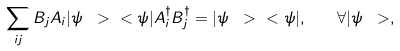Convert formula to latex. <formula><loc_0><loc_0><loc_500><loc_500>\sum _ { i j } B _ { j } A _ { i } | \psi \ > \ < \psi | A _ { i } ^ { \dag } B _ { j } ^ { \dag } = | \psi \ > \ < \psi | , \quad \forall | \psi \ > ,</formula> 